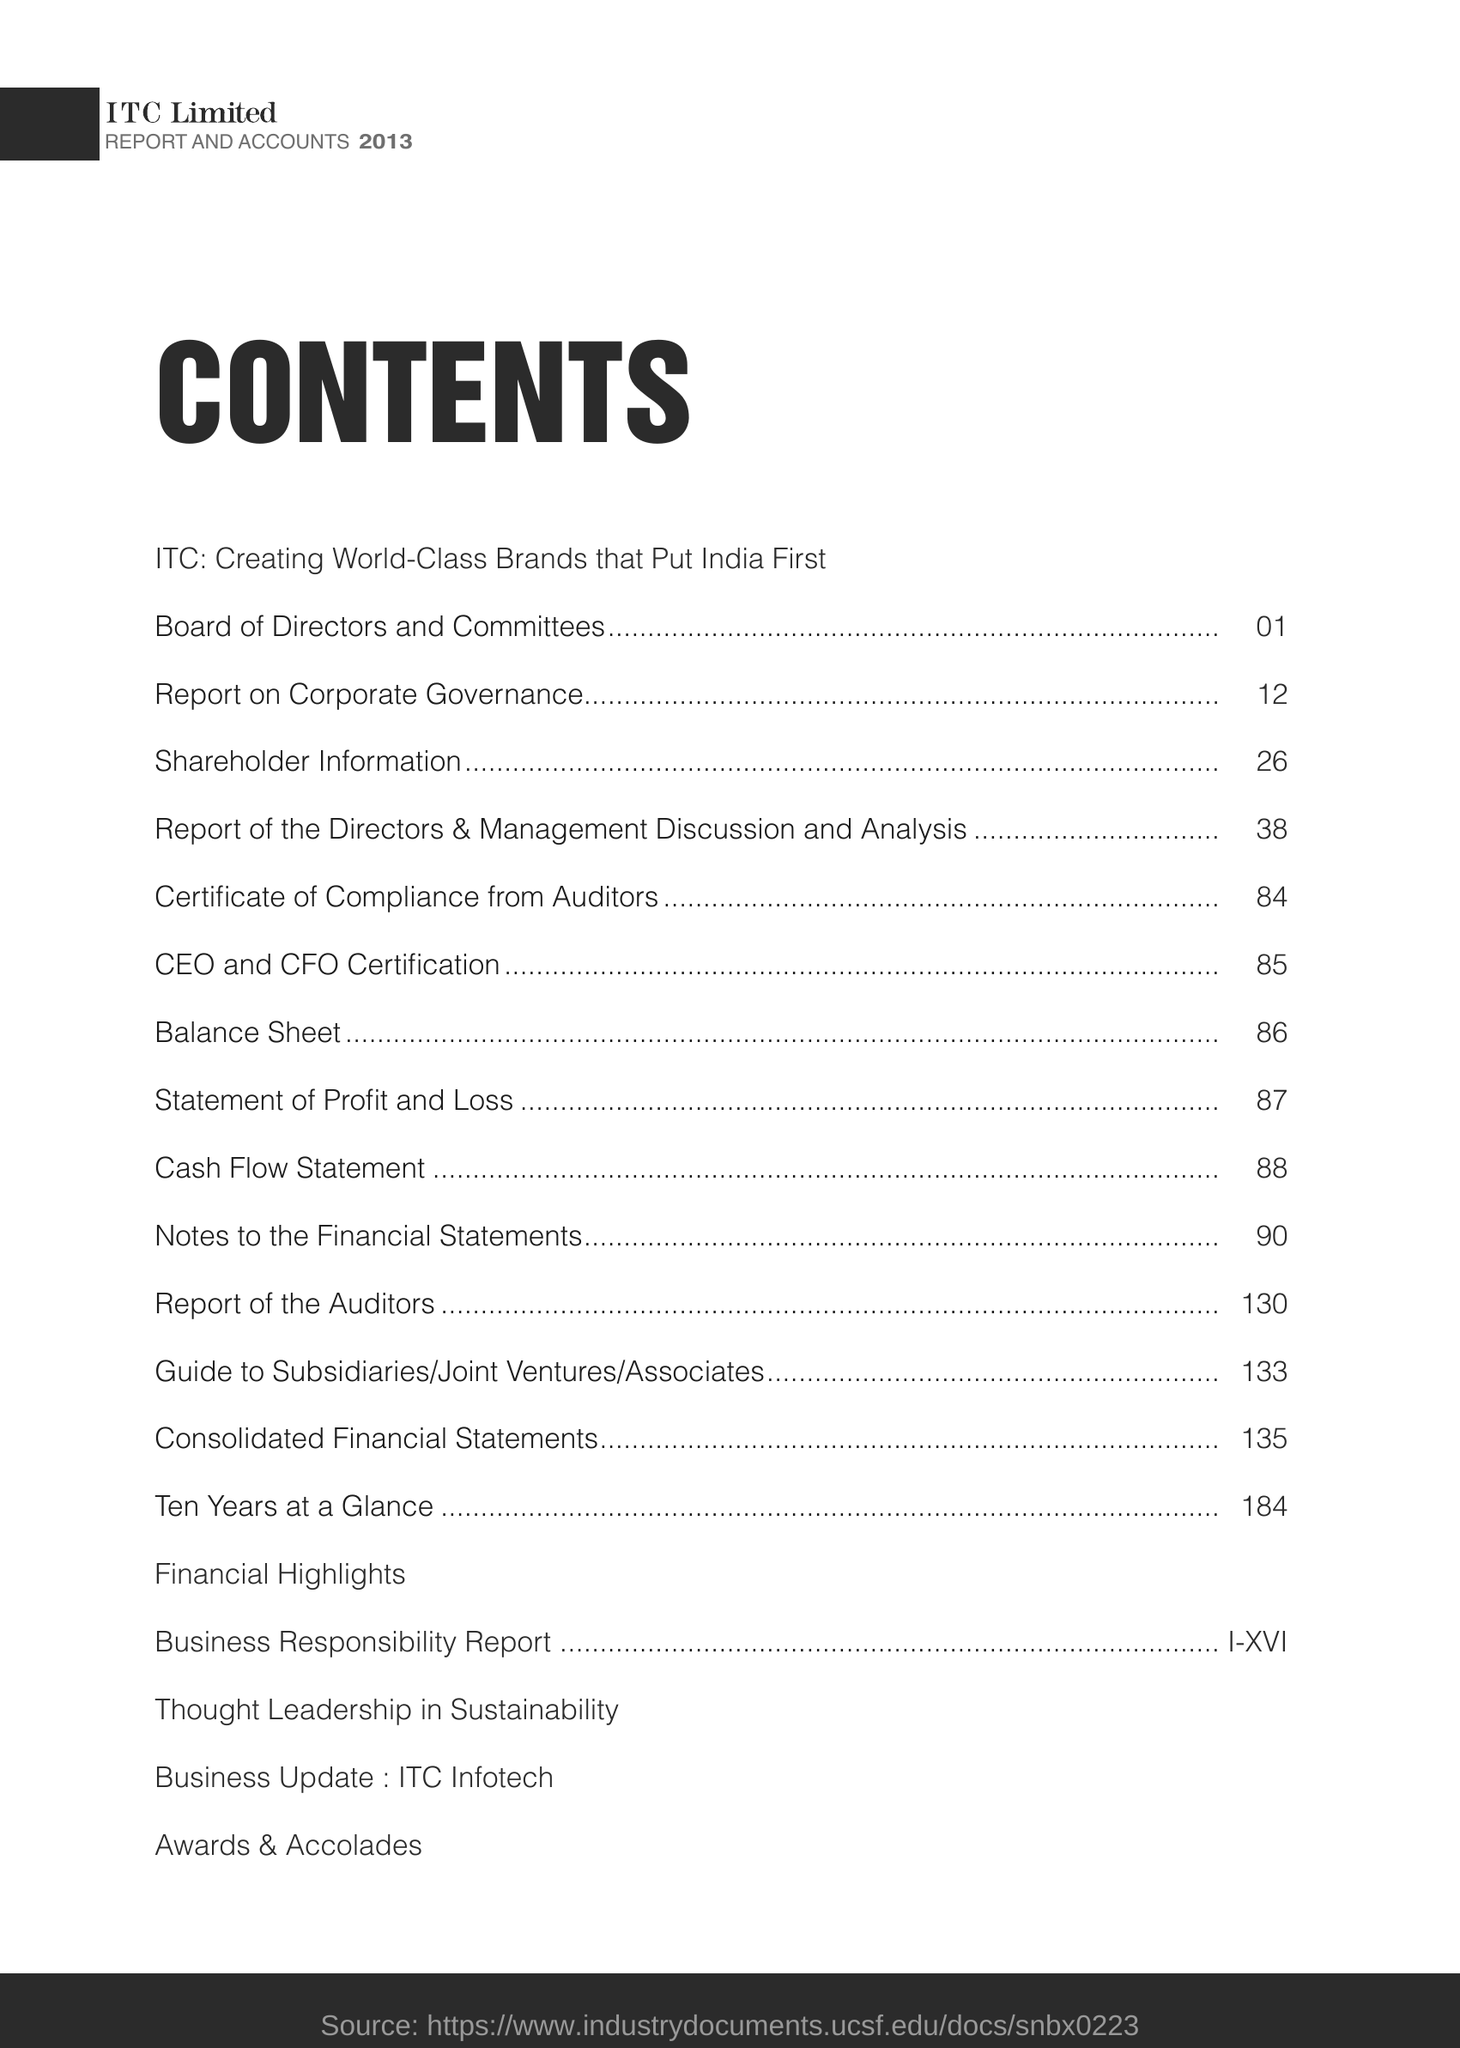Specify some key components in this picture. The page number for shareholders information is 26. The topic showing page number 86 is the balance sheet. 